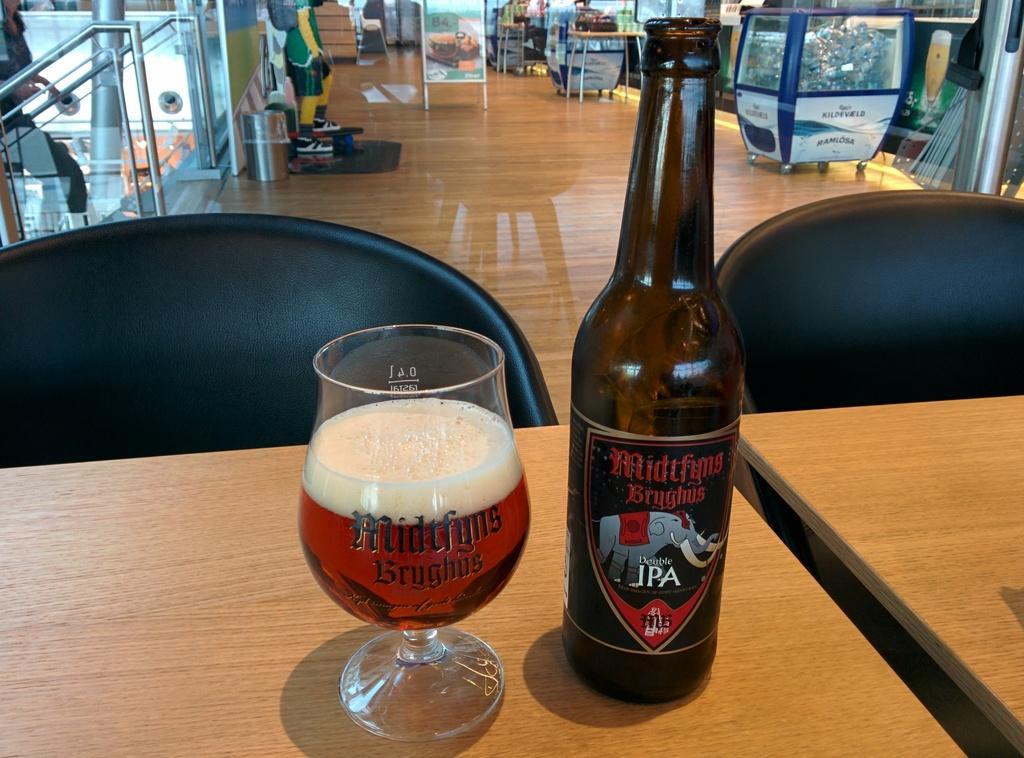<image>
Render a clear and concise summary of the photo. A bottle of Midtfyms Bryghus next to a half full glass. 